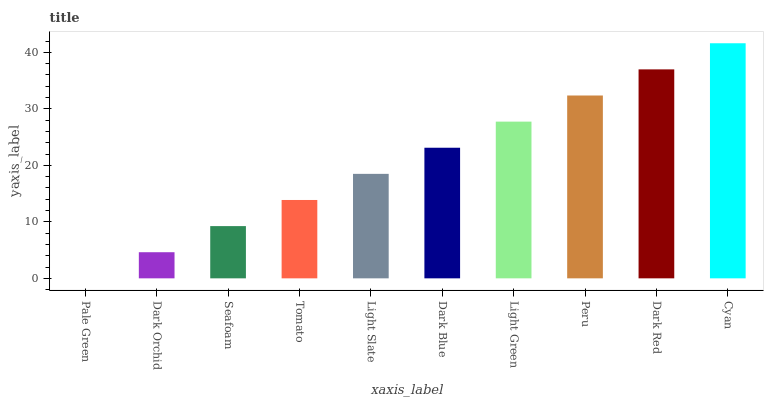Is Pale Green the minimum?
Answer yes or no. Yes. Is Cyan the maximum?
Answer yes or no. Yes. Is Dark Orchid the minimum?
Answer yes or no. No. Is Dark Orchid the maximum?
Answer yes or no. No. Is Dark Orchid greater than Pale Green?
Answer yes or no. Yes. Is Pale Green less than Dark Orchid?
Answer yes or no. Yes. Is Pale Green greater than Dark Orchid?
Answer yes or no. No. Is Dark Orchid less than Pale Green?
Answer yes or no. No. Is Dark Blue the high median?
Answer yes or no. Yes. Is Light Slate the low median?
Answer yes or no. Yes. Is Seafoam the high median?
Answer yes or no. No. Is Light Green the low median?
Answer yes or no. No. 